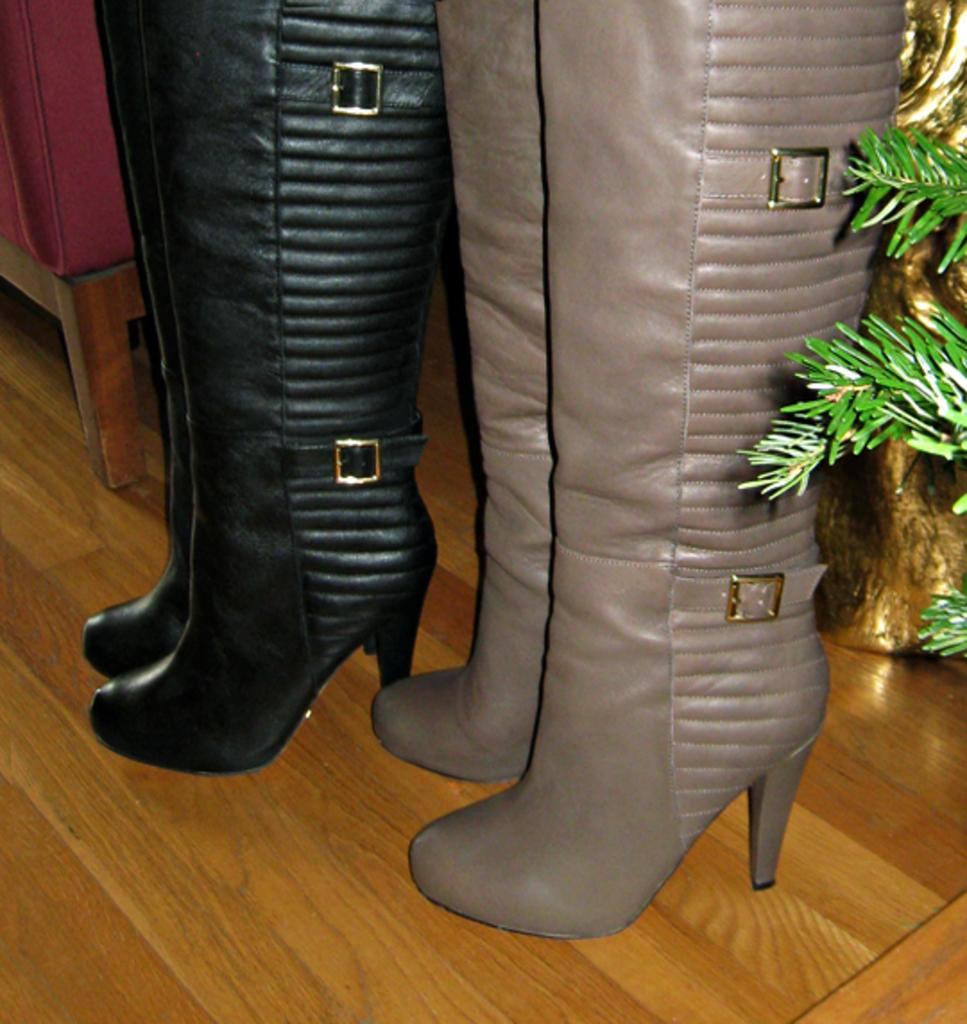How many pairs of boots are in the image? There are two pairs of boots in the image. What are the colors of the two pairs of boots? One pair of boots is black in color, and the other pair is pale brown in color. What type of surface can be seen in the image? There is a wooden surface in the image. What type of natural elements are present in the image? Leaves are present in the image. What type of can is visible in the image? There is no can present in the image. Is there a gate visible in the image? There is no gate present in the image. 